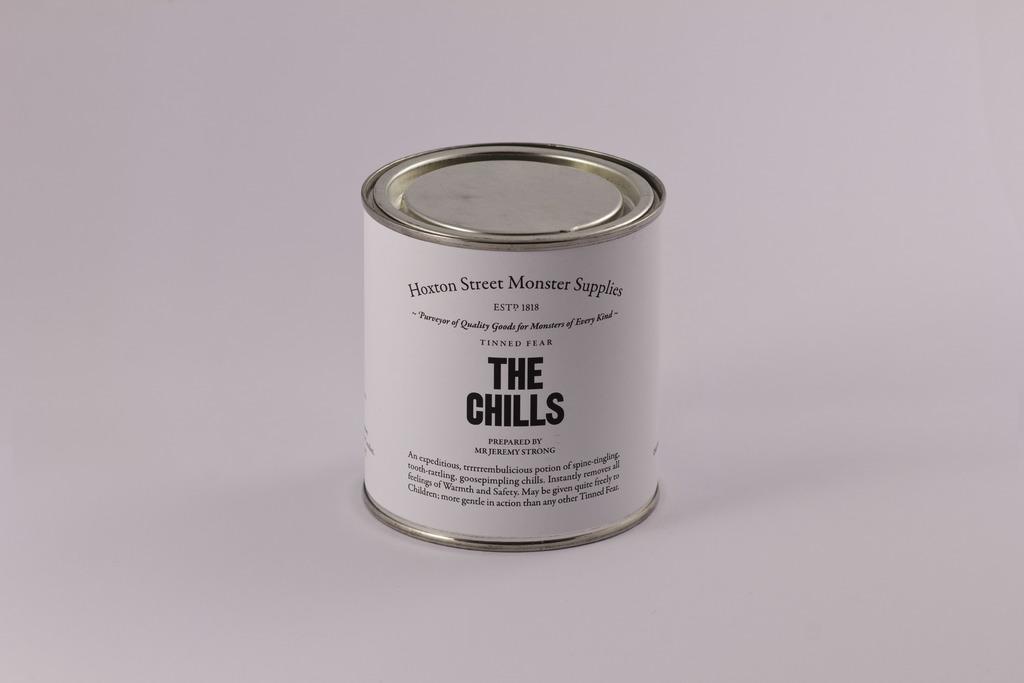What is the name of the brand displayed in the can?
Make the answer very short. The chills. What year is on the can?
Your answer should be compact. 1818. 